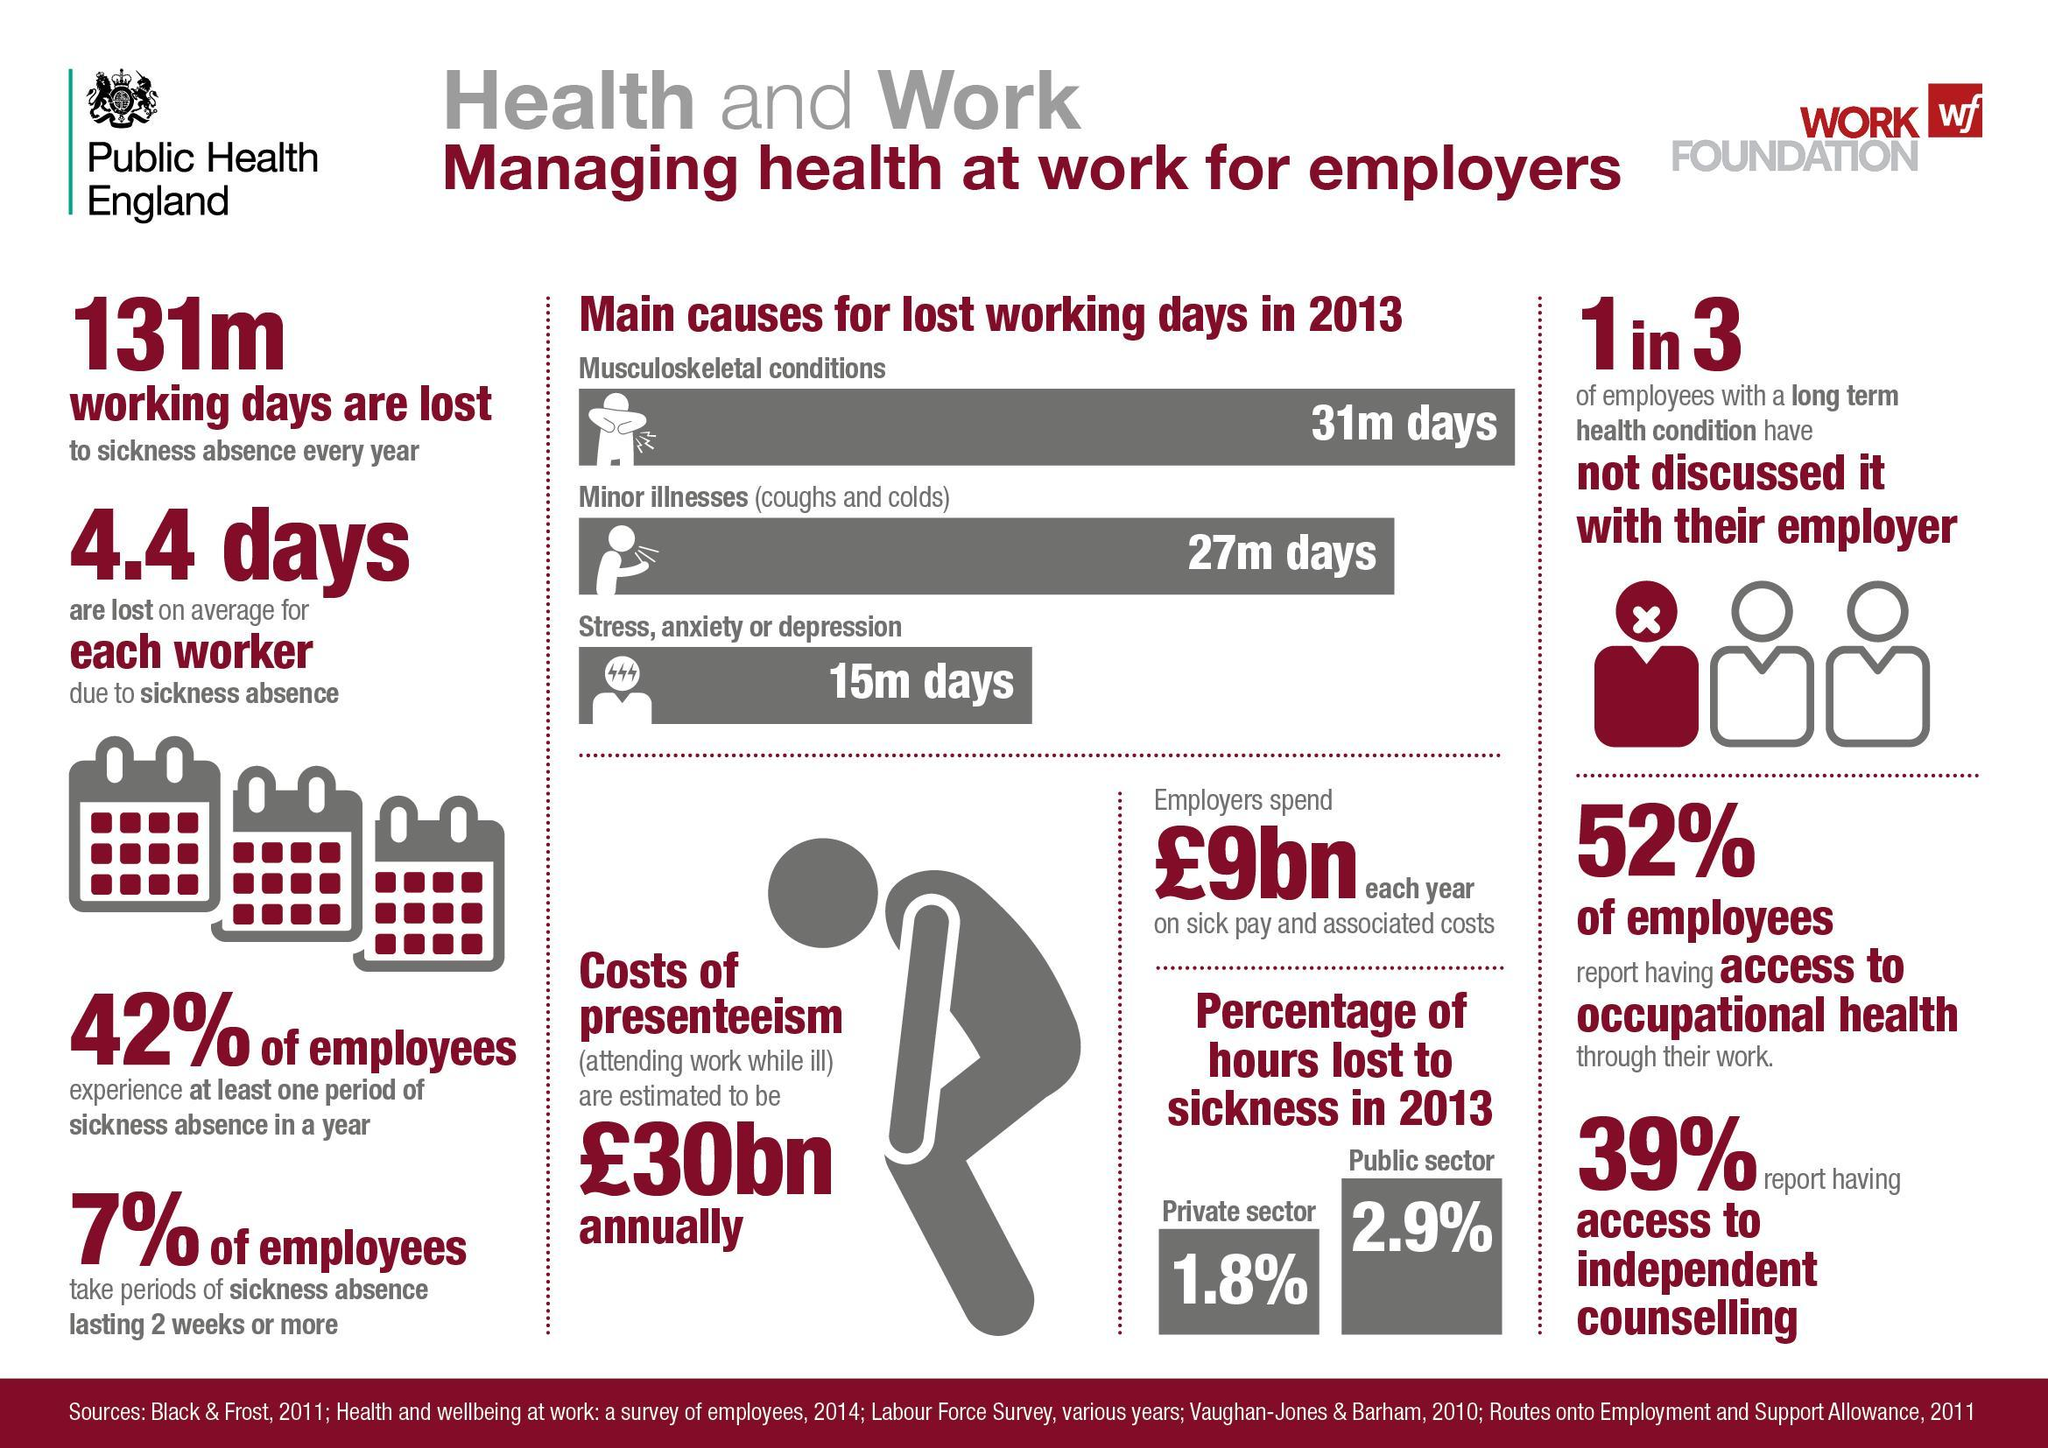What is 'presenteeism'?
Answer the question with a short phrase. Attending work while ill What is the percentage of hours lost due to sickness in the private sector? 1.8% On an average how many days are lost per week, due to sickness? 4.4 How many working days were lost due to musculoskeletal conditions in 2013? 31m What percent of employees experience at least one period of sickness absence in a year? 42% What is the annual cost of presenteeism (£bn)? 30 How many working days are lost due to sickness absence every year? 131m What percentage of employees take periods of sickness absence lasting 2 weeks or more? 7% What percent of employees have access to occupational health? 52% How many working days were lost due to stress anxiety or depression? 15m How many working days were lost due to minor illnesses in 2013? 27m What percent of employees have access to independent counselling? 39% 